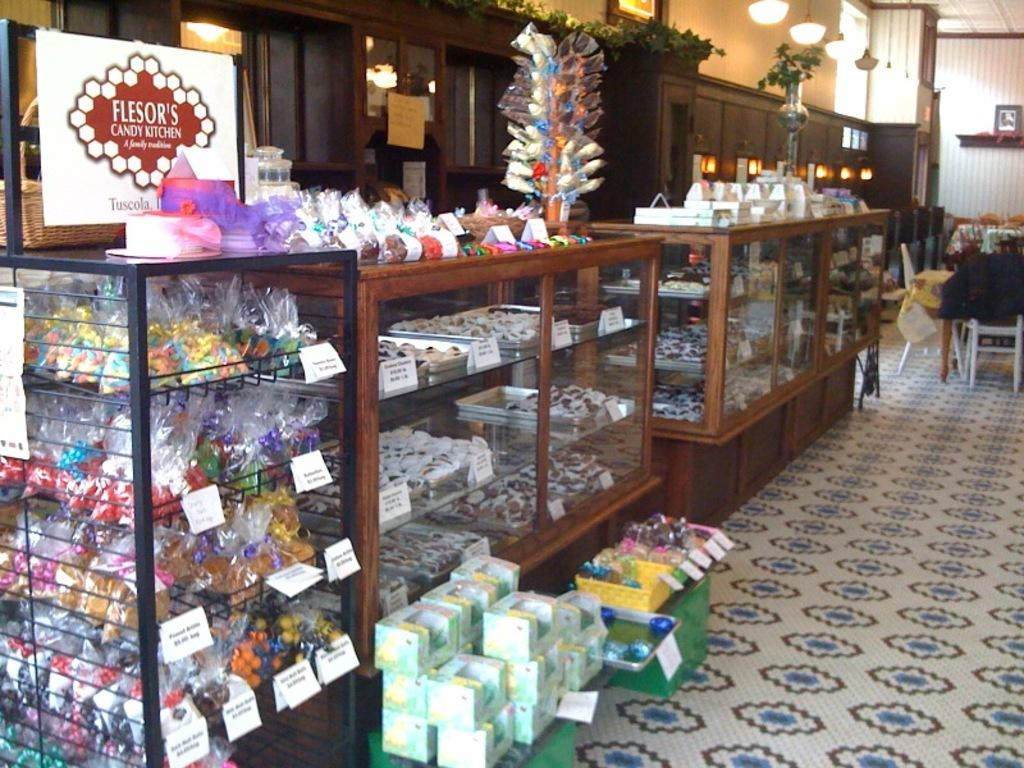<image>
Create a compact narrative representing the image presented. A display of sweets from a place called Flesor's Candy Kitchen. 